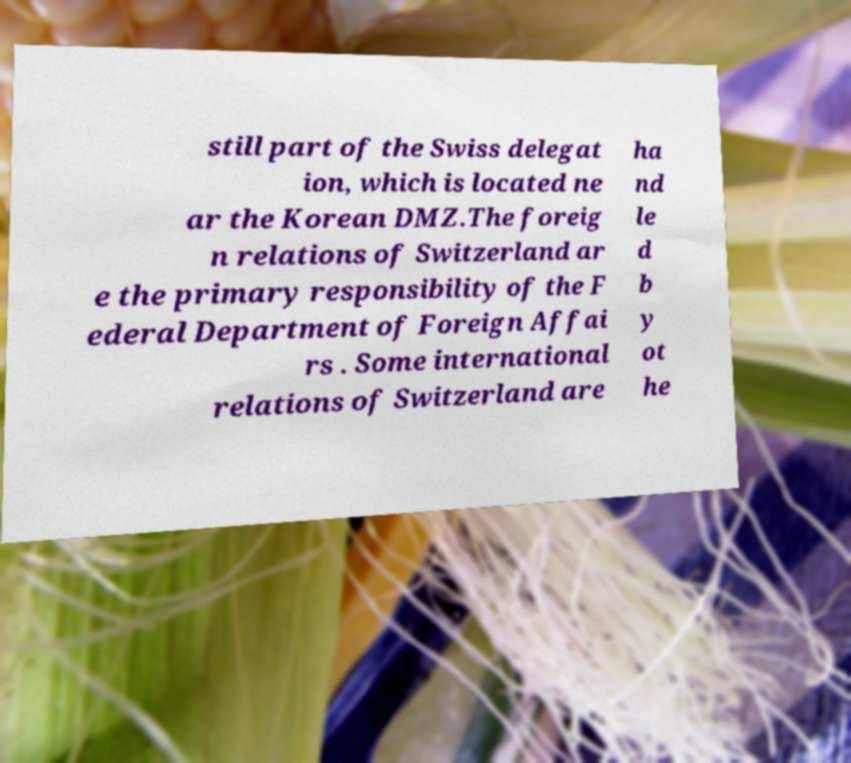I need the written content from this picture converted into text. Can you do that? still part of the Swiss delegat ion, which is located ne ar the Korean DMZ.The foreig n relations of Switzerland ar e the primary responsibility of the F ederal Department of Foreign Affai rs . Some international relations of Switzerland are ha nd le d b y ot he 